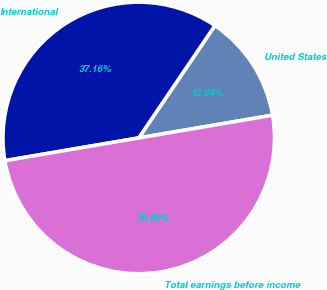Convert chart. <chart><loc_0><loc_0><loc_500><loc_500><pie_chart><fcel>United States<fcel>International<fcel>Total earnings before income<nl><fcel>12.84%<fcel>37.16%<fcel>50.0%<nl></chart> 